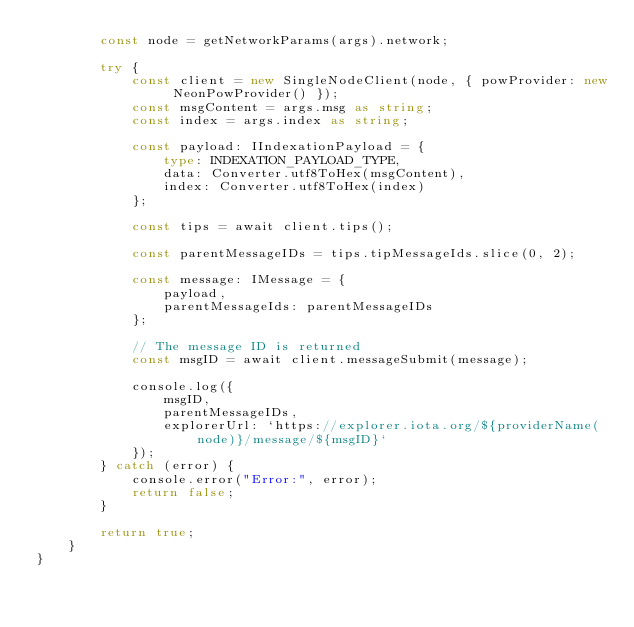<code> <loc_0><loc_0><loc_500><loc_500><_TypeScript_>        const node = getNetworkParams(args).network;

        try {
            const client = new SingleNodeClient(node, { powProvider: new NeonPowProvider() });
            const msgContent = args.msg as string;
            const index = args.index as string;

            const payload: IIndexationPayload = {
                type: INDEXATION_PAYLOAD_TYPE,
                data: Converter.utf8ToHex(msgContent),
                index: Converter.utf8ToHex(index)
            };

            const tips = await client.tips();

            const parentMessageIDs = tips.tipMessageIds.slice(0, 2);

            const message: IMessage = {
                payload,
                parentMessageIds: parentMessageIDs
            };

            // The message ID is returned
            const msgID = await client.messageSubmit(message);

            console.log({
                msgID,
                parentMessageIDs,
                explorerUrl: `https://explorer.iota.org/${providerName(node)}/message/${msgID}`
            });
        } catch (error) {
            console.error("Error:", error);
            return false;
        }

        return true;
    }
}
</code> 